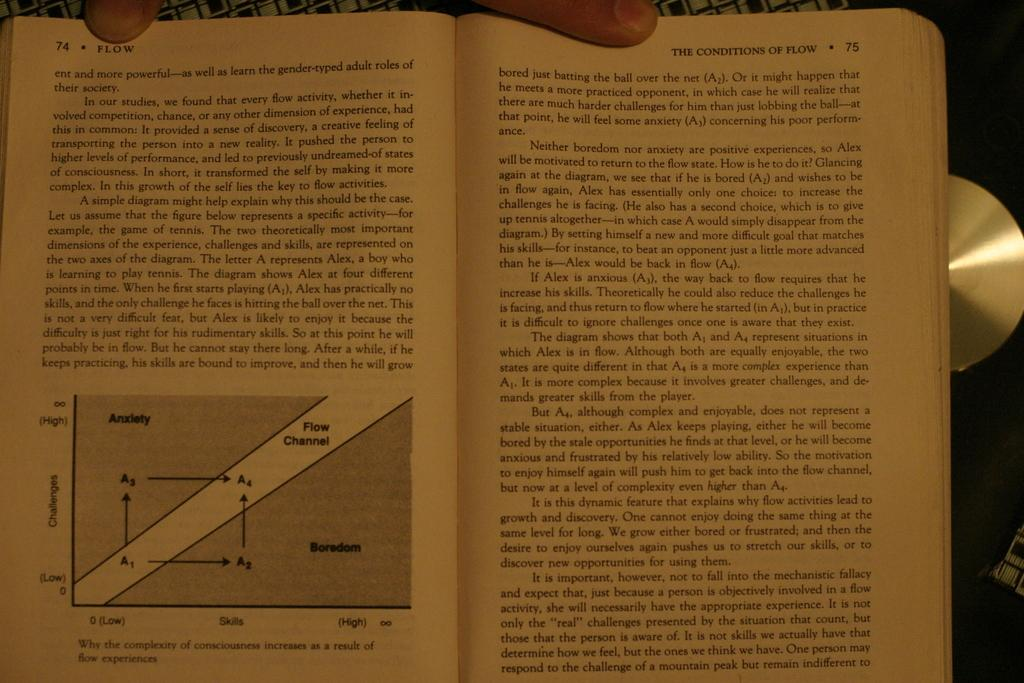<image>
Offer a succinct explanation of the picture presented. A book titled The Conditions of Flow is open to page 74. 